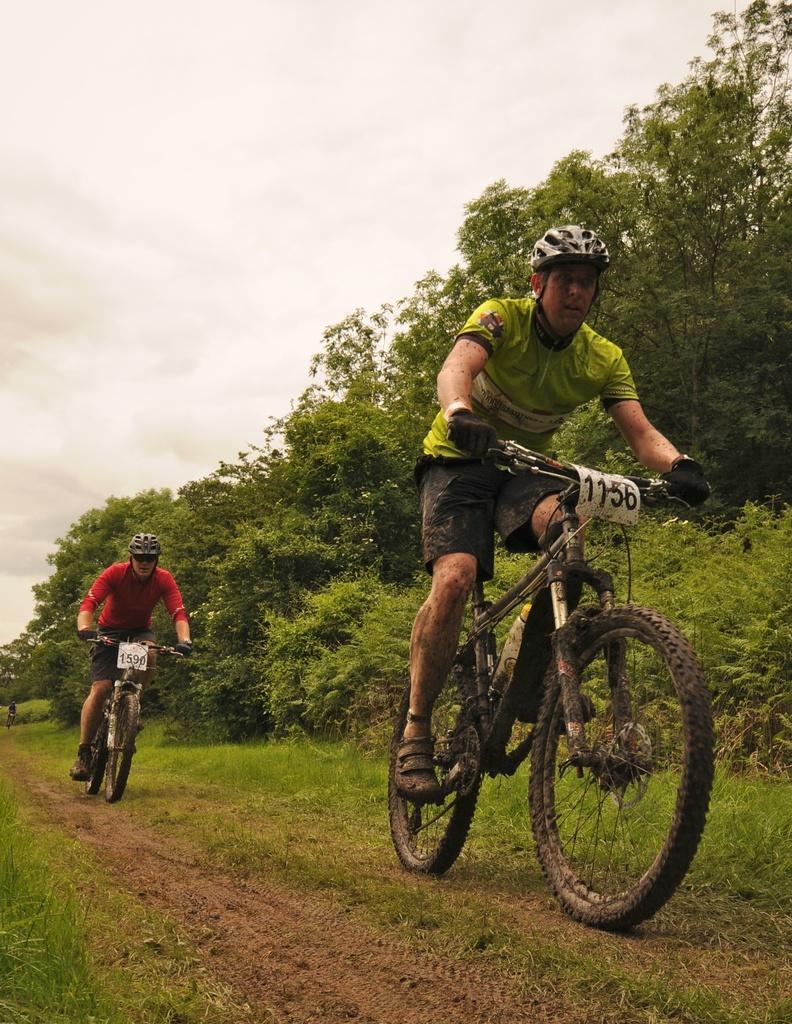What are the people in the image doing? The people in the image are cycling. What type of vehicles are the people using? The people are riding bicycles. What can be seen in the foreground of the image? There is a path visible in the image. What is visible in the background of the image? There are trees in the background of the image. What safety precaution are the people taking while cycling? The people are wearing helmets. Can you see any fairies flying around the cyclists in the image? There are no fairies present in the image; it features people cycling on a path with trees in the background. 